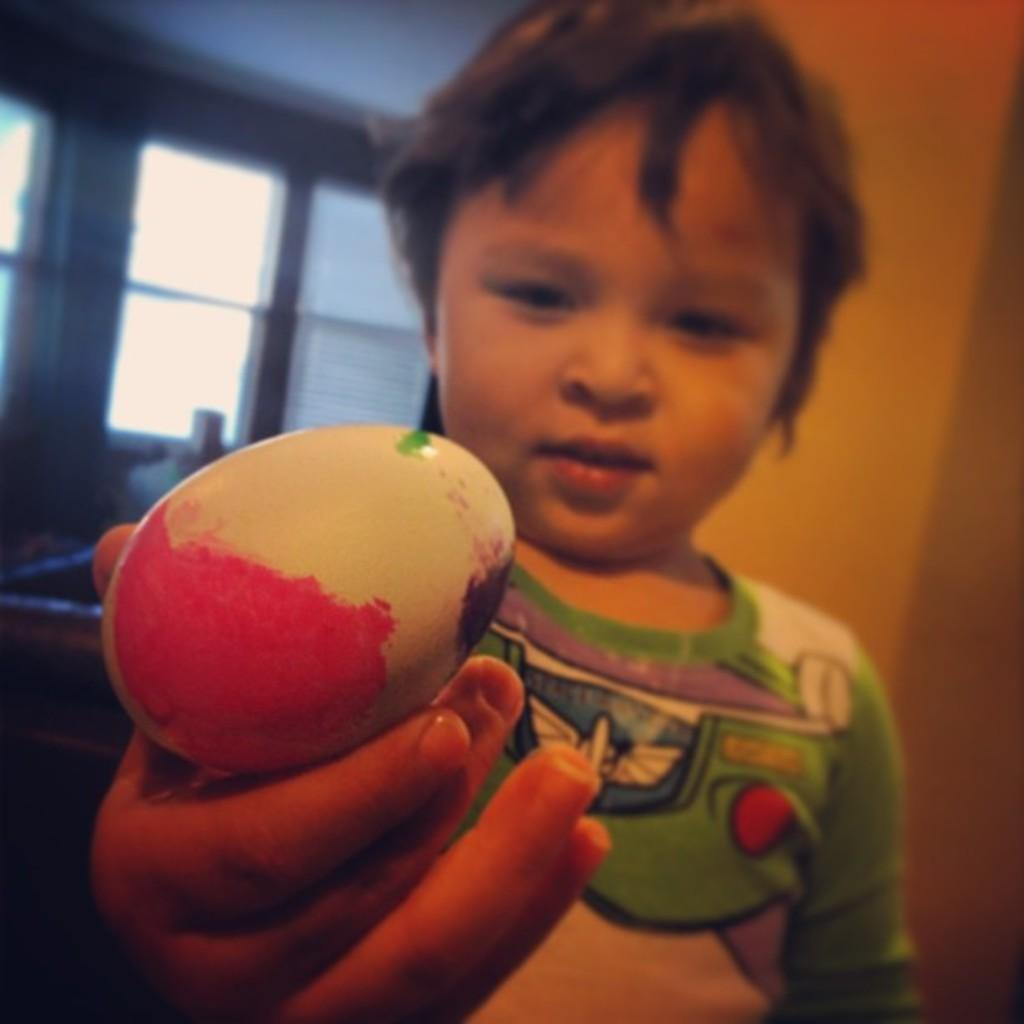Who is in the image? There is a boy in the image. What is the boy doing? The boy is standing. What is the boy holding in his hand? The boy is holding an egg in his hand. What can be seen on the right side of the image? There is a wall on the right side of the image. What is visible in the background of the image? There is a window visible in the background of the image. What type of cream can be seen on the boy's face in the image? There is no cream visible on the boy's face in the image. Is there a goldfish swimming in the window in the image? There is no goldfish present in the image; the window is visible in the background, but it does not contain any fish. 